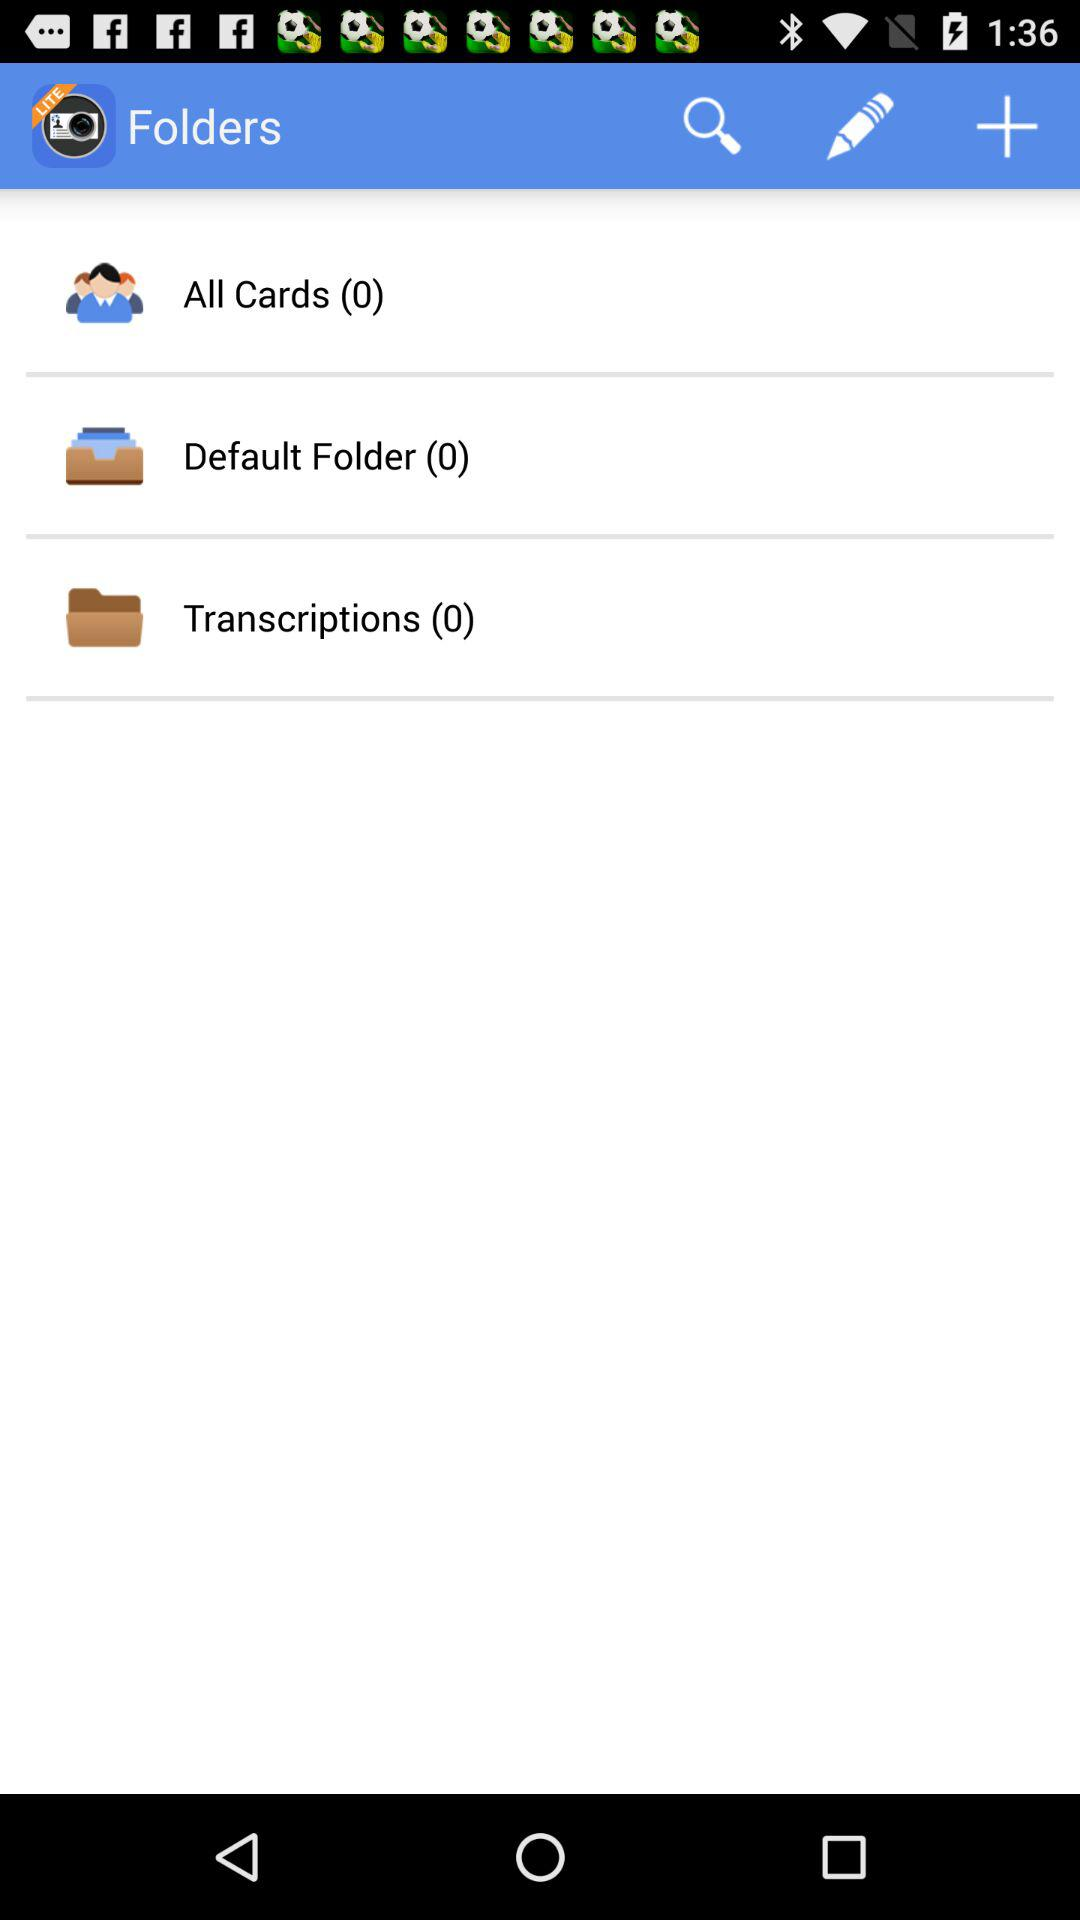When was the "Transcriptions" folder created?
When the provided information is insufficient, respond with <no answer>. <no answer> 